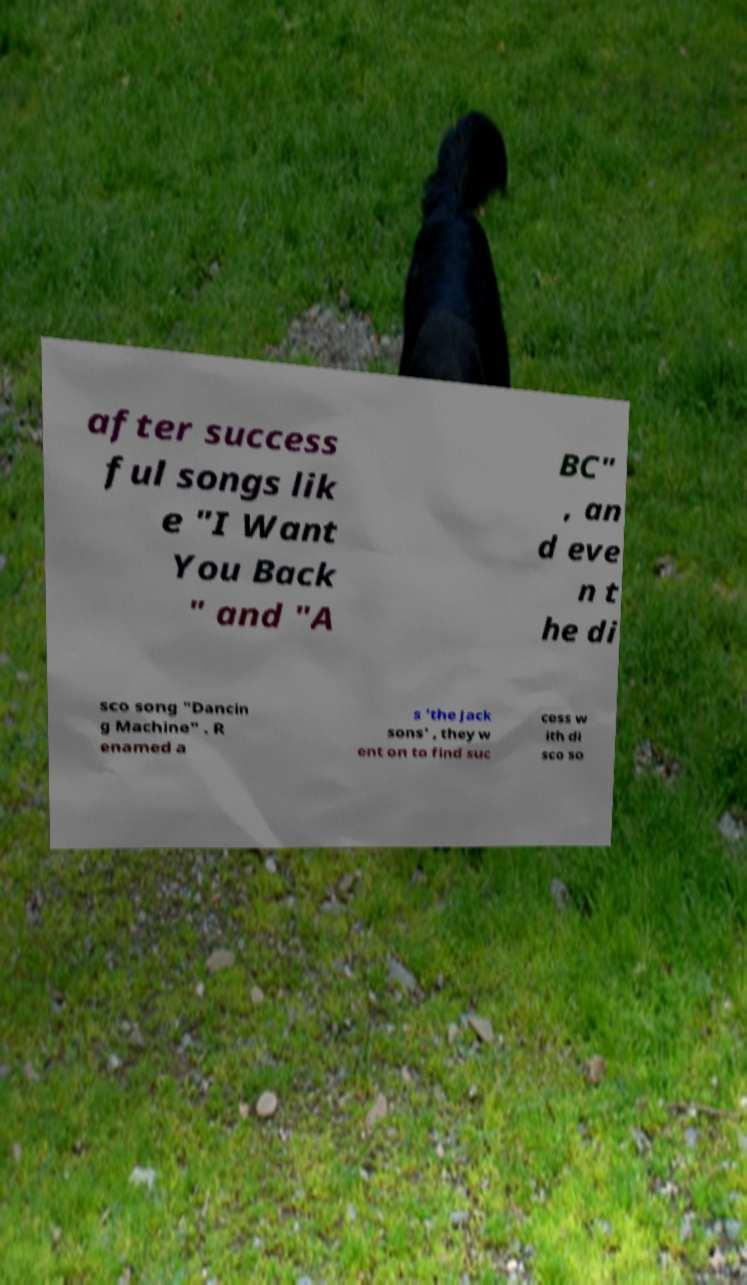Could you extract and type out the text from this image? after success ful songs lik e "I Want You Back " and "A BC" , an d eve n t he di sco song "Dancin g Machine" . R enamed a s 'the Jack sons' , they w ent on to find suc cess w ith di sco so 